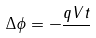Convert formula to latex. <formula><loc_0><loc_0><loc_500><loc_500>\Delta \phi = - \frac { q V t } { }</formula> 